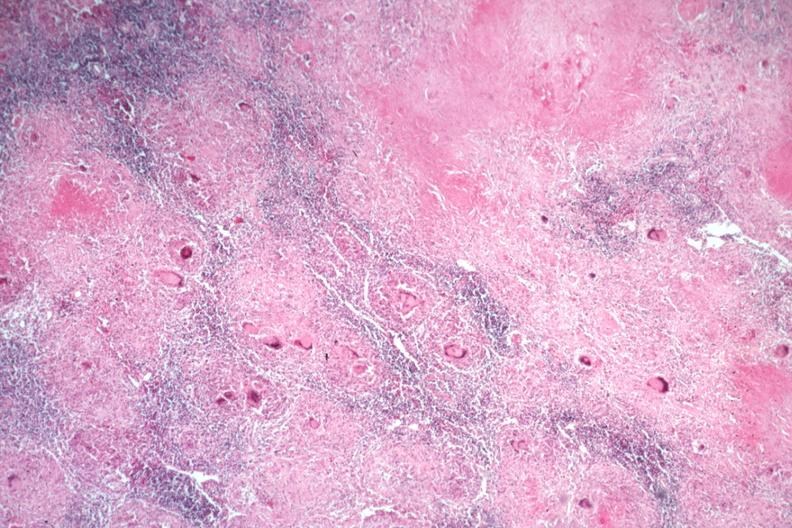what is present?
Answer the question using a single word or phrase. Tuberculosis 